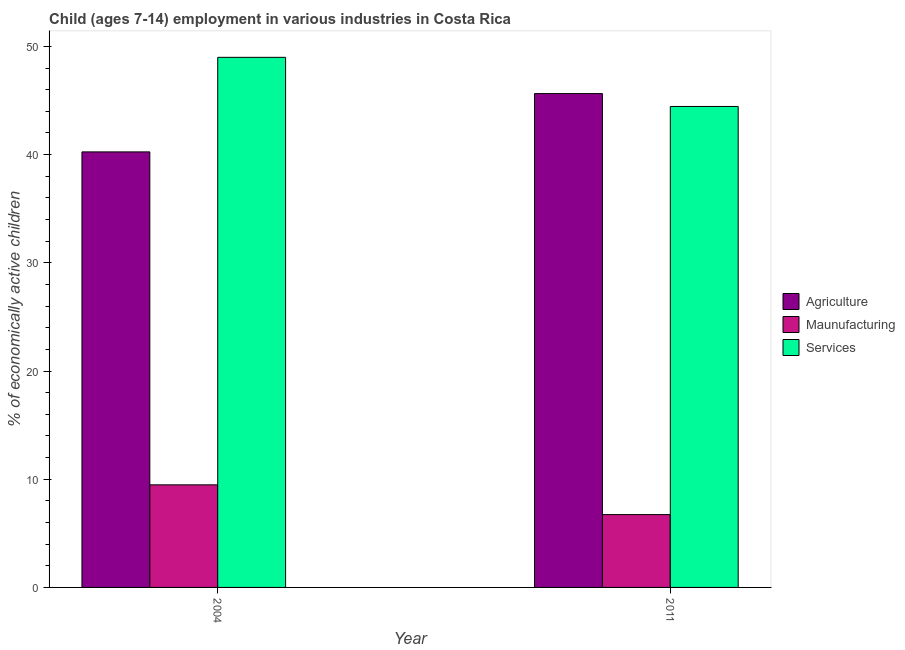How many groups of bars are there?
Make the answer very short. 2. Are the number of bars per tick equal to the number of legend labels?
Your answer should be very brief. Yes. Are the number of bars on each tick of the X-axis equal?
Give a very brief answer. Yes. How many bars are there on the 2nd tick from the left?
Offer a very short reply. 3. How many bars are there on the 2nd tick from the right?
Provide a short and direct response. 3. What is the label of the 2nd group of bars from the left?
Your answer should be compact. 2011. What is the percentage of economically active children in agriculture in 2011?
Give a very brief answer. 45.64. Across all years, what is the maximum percentage of economically active children in manufacturing?
Your answer should be very brief. 9.48. Across all years, what is the minimum percentage of economically active children in services?
Your answer should be compact. 44.45. What is the total percentage of economically active children in agriculture in the graph?
Offer a terse response. 85.89. What is the difference between the percentage of economically active children in agriculture in 2004 and that in 2011?
Give a very brief answer. -5.39. What is the difference between the percentage of economically active children in agriculture in 2011 and the percentage of economically active children in manufacturing in 2004?
Provide a short and direct response. 5.39. What is the average percentage of economically active children in manufacturing per year?
Give a very brief answer. 8.11. In the year 2004, what is the difference between the percentage of economically active children in services and percentage of economically active children in manufacturing?
Make the answer very short. 0. In how many years, is the percentage of economically active children in manufacturing greater than 40 %?
Provide a succinct answer. 0. What is the ratio of the percentage of economically active children in services in 2004 to that in 2011?
Offer a very short reply. 1.1. What does the 2nd bar from the left in 2011 represents?
Provide a succinct answer. Maunufacturing. What does the 3rd bar from the right in 2011 represents?
Make the answer very short. Agriculture. How many bars are there?
Ensure brevity in your answer.  6. Are all the bars in the graph horizontal?
Your response must be concise. No. How many years are there in the graph?
Offer a terse response. 2. What is the difference between two consecutive major ticks on the Y-axis?
Give a very brief answer. 10. Are the values on the major ticks of Y-axis written in scientific E-notation?
Provide a short and direct response. No. Does the graph contain any zero values?
Give a very brief answer. No. What is the title of the graph?
Offer a very short reply. Child (ages 7-14) employment in various industries in Costa Rica. What is the label or title of the X-axis?
Keep it short and to the point. Year. What is the label or title of the Y-axis?
Offer a very short reply. % of economically active children. What is the % of economically active children in Agriculture in 2004?
Give a very brief answer. 40.25. What is the % of economically active children in Maunufacturing in 2004?
Provide a succinct answer. 9.48. What is the % of economically active children in Services in 2004?
Give a very brief answer. 48.99. What is the % of economically active children of Agriculture in 2011?
Provide a short and direct response. 45.64. What is the % of economically active children of Maunufacturing in 2011?
Provide a short and direct response. 6.73. What is the % of economically active children in Services in 2011?
Ensure brevity in your answer.  44.45. Across all years, what is the maximum % of economically active children of Agriculture?
Offer a terse response. 45.64. Across all years, what is the maximum % of economically active children of Maunufacturing?
Your answer should be compact. 9.48. Across all years, what is the maximum % of economically active children in Services?
Provide a succinct answer. 48.99. Across all years, what is the minimum % of economically active children of Agriculture?
Provide a succinct answer. 40.25. Across all years, what is the minimum % of economically active children in Maunufacturing?
Provide a succinct answer. 6.73. Across all years, what is the minimum % of economically active children in Services?
Make the answer very short. 44.45. What is the total % of economically active children in Agriculture in the graph?
Make the answer very short. 85.89. What is the total % of economically active children of Maunufacturing in the graph?
Your response must be concise. 16.21. What is the total % of economically active children of Services in the graph?
Offer a very short reply. 93.44. What is the difference between the % of economically active children of Agriculture in 2004 and that in 2011?
Offer a very short reply. -5.39. What is the difference between the % of economically active children in Maunufacturing in 2004 and that in 2011?
Your answer should be compact. 2.75. What is the difference between the % of economically active children in Services in 2004 and that in 2011?
Offer a very short reply. 4.54. What is the difference between the % of economically active children of Agriculture in 2004 and the % of economically active children of Maunufacturing in 2011?
Your response must be concise. 33.52. What is the difference between the % of economically active children of Maunufacturing in 2004 and the % of economically active children of Services in 2011?
Offer a terse response. -34.97. What is the average % of economically active children in Agriculture per year?
Ensure brevity in your answer.  42.95. What is the average % of economically active children of Maunufacturing per year?
Give a very brief answer. 8.11. What is the average % of economically active children in Services per year?
Offer a very short reply. 46.72. In the year 2004, what is the difference between the % of economically active children of Agriculture and % of economically active children of Maunufacturing?
Ensure brevity in your answer.  30.77. In the year 2004, what is the difference between the % of economically active children in Agriculture and % of economically active children in Services?
Keep it short and to the point. -8.74. In the year 2004, what is the difference between the % of economically active children of Maunufacturing and % of economically active children of Services?
Make the answer very short. -39.51. In the year 2011, what is the difference between the % of economically active children in Agriculture and % of economically active children in Maunufacturing?
Ensure brevity in your answer.  38.91. In the year 2011, what is the difference between the % of economically active children in Agriculture and % of economically active children in Services?
Your answer should be very brief. 1.19. In the year 2011, what is the difference between the % of economically active children in Maunufacturing and % of economically active children in Services?
Make the answer very short. -37.72. What is the ratio of the % of economically active children in Agriculture in 2004 to that in 2011?
Provide a succinct answer. 0.88. What is the ratio of the % of economically active children in Maunufacturing in 2004 to that in 2011?
Keep it short and to the point. 1.41. What is the ratio of the % of economically active children in Services in 2004 to that in 2011?
Your answer should be very brief. 1.1. What is the difference between the highest and the second highest % of economically active children in Agriculture?
Offer a terse response. 5.39. What is the difference between the highest and the second highest % of economically active children in Maunufacturing?
Offer a very short reply. 2.75. What is the difference between the highest and the second highest % of economically active children in Services?
Provide a short and direct response. 4.54. What is the difference between the highest and the lowest % of economically active children of Agriculture?
Make the answer very short. 5.39. What is the difference between the highest and the lowest % of economically active children in Maunufacturing?
Ensure brevity in your answer.  2.75. What is the difference between the highest and the lowest % of economically active children of Services?
Give a very brief answer. 4.54. 